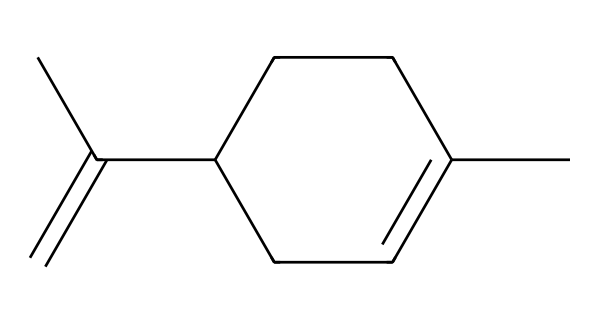How many carbon atoms are in limonene? By examining the SMILES representation, we see "CC" indicates two carbon atoms, while "C" is used repeatedly for each carbon in the chain and rings, leading to a total count of six carbon atoms in total.
Answer: six What is the degree of unsaturation in limonene? The degree of unsaturation can be calculated by identifying double bonds and rings. In the structure, there are two double bonds and no rings, which gives a degree of unsaturation of two.
Answer: two What functional group is primarily responsible for the citrus scent of limonene? Limonene contains a double bond (alkene), and this unsaturation contributes to its characteristic citrus aroma, which is typical in flavors and fragrances.
Answer: alkene Is limonene a cyclic compound? While analyzing the structure, it can be observed that the core structure of limonene is composed of a non-cyclic chain, indicating that it is not a cyclic compound.
Answer: no What type of scent is limonene typically associated with? Limonene is widely recognized for its fresh, citrus scent, which is commonly used in various perfumes and cosmetic products, catering to those who prefer fruity fragrances.
Answer: citrus What property of limonene makes it suitable for niche perfumes? The unique blend of its structure enables limonene to provide a strong, refreshing scent that can complement various fragrance notes, making it highly sought after in niche markets.
Answer: refreshing scent 